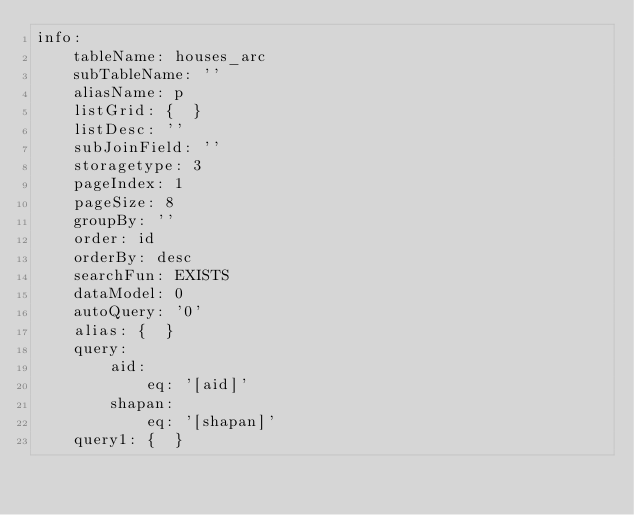Convert code to text. <code><loc_0><loc_0><loc_500><loc_500><_YAML_>info:
    tableName: houses_arc
    subTableName: ''
    aliasName: p
    listGrid: {  }
    listDesc: ''
    subJoinField: ''
    storagetype: 3
    pageIndex: 1
    pageSize: 8
    groupBy: ''
    order: id
    orderBy: desc
    searchFun: EXISTS
    dataModel: 0
    autoQuery: '0'
    alias: {  }
    query:
        aid:
            eq: '[aid]'
        shapan:
            eq: '[shapan]'
    query1: {  }
</code> 